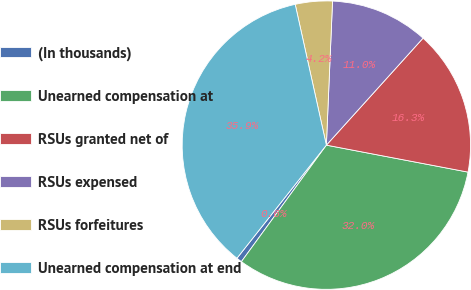Convert chart. <chart><loc_0><loc_0><loc_500><loc_500><pie_chart><fcel>(In thousands)<fcel>Unearned compensation at<fcel>RSUs granted net of<fcel>RSUs expensed<fcel>RSUs forfeitures<fcel>Unearned compensation at end<nl><fcel>0.62%<fcel>32.03%<fcel>16.3%<fcel>11.01%<fcel>4.15%<fcel>35.88%<nl></chart> 